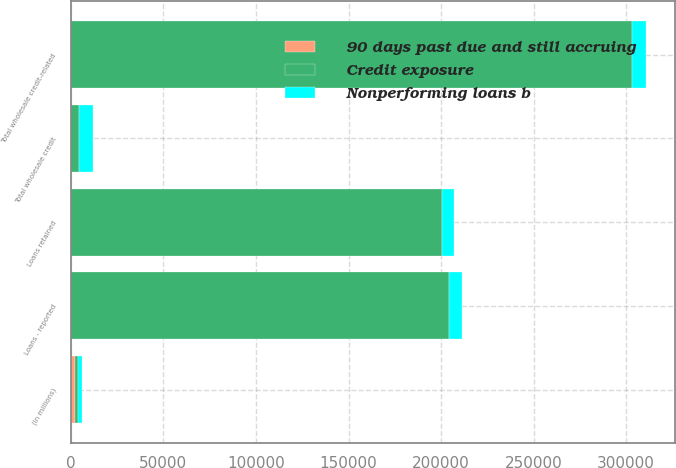<chart> <loc_0><loc_0><loc_500><loc_500><stacked_bar_chart><ecel><fcel>(in millions)<fcel>Loans retained<fcel>Loans - reported<fcel>Total wholesale credit-related<fcel>Total wholesale credit<nl><fcel>Credit exposure<fcel>2009<fcel>200077<fcel>204175<fcel>303057<fcel>4284<nl><fcel>Nonperforming loans b<fcel>2009<fcel>6559<fcel>6904<fcel>7433<fcel>7433<nl><fcel>90 days past due and still accruing<fcel>2009<fcel>332<fcel>332<fcel>332<fcel>332<nl></chart> 